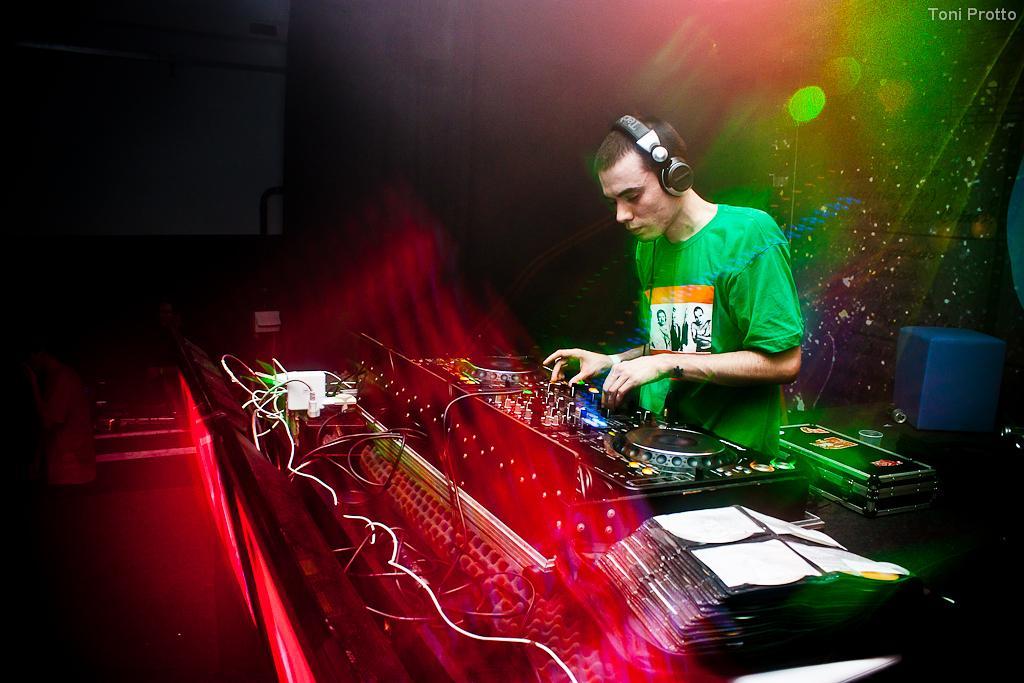Could you give a brief overview of what you see in this image? In this picture I can see a man in front, who is wearing a t-shirt and I see few electronic equipment near him and I can see the colorful background. On the top of this picture I can see the watermark and I see that it is a bit dark on the left side of this image. 